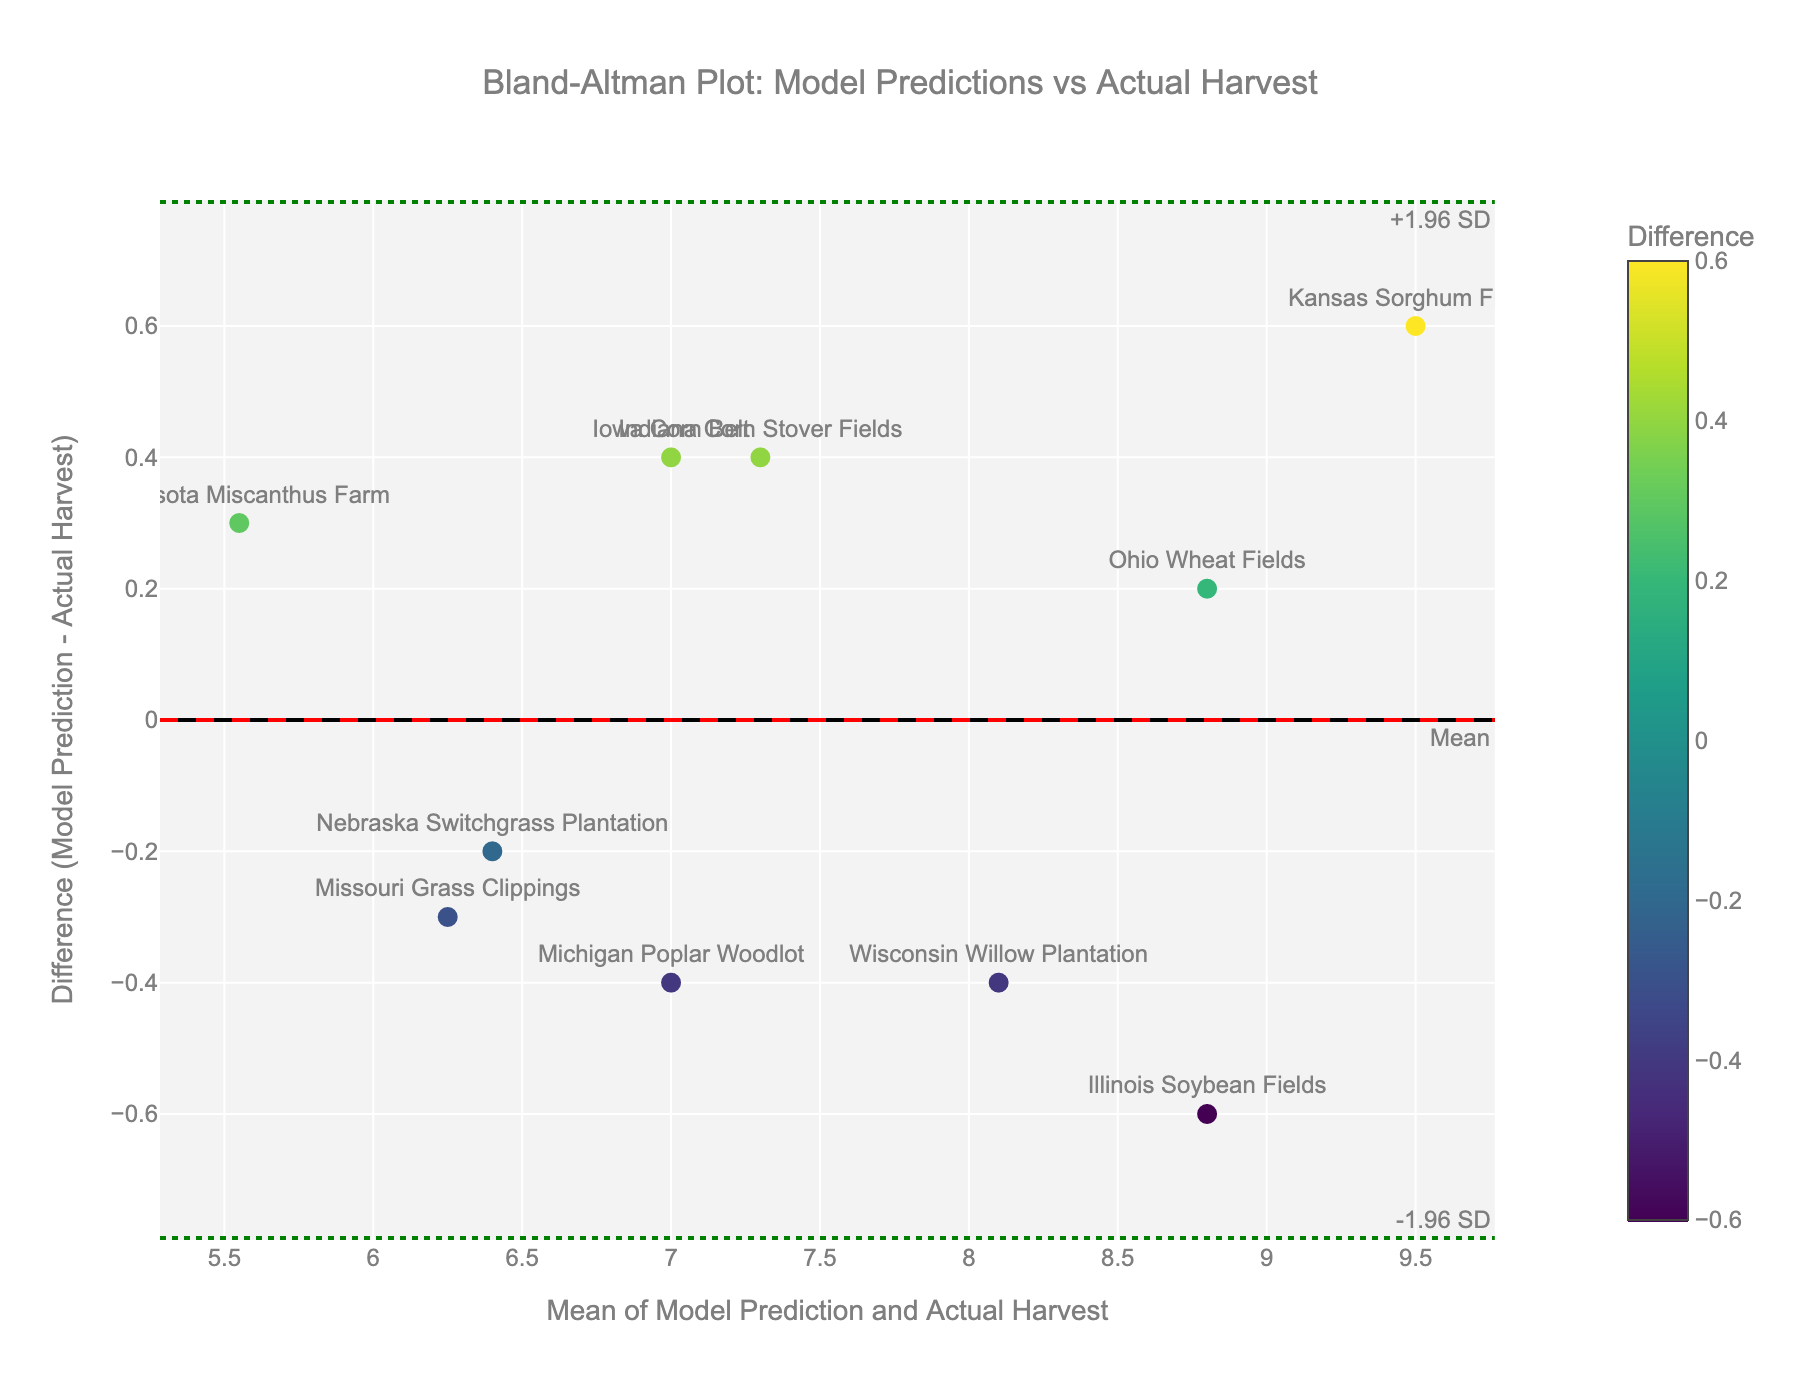How many data points are shown in the Bland-Altman plot? By counting each marker representing a location on the plot, we can identify 10 data points.
Answer: 10 What is the title of the plot? The title is found at the top center of the plot area. It reads: "Bland-Altman Plot: Model Predictions vs Actual Harvest".
Answer: Bland-Altman Plot: Model Predictions vs Actual Harvest What is the color of the mean difference line? The mean difference line is indicated by a horizontal dashed line colored in red.
Answer: Red Which location has the largest negative difference between model prediction and actual harvest? By examining the vertical positions of the markers on the y-axis, "Kansas Sorghum Fields" has the lowest (most negative) difference value among the data points, below the red mean difference line.
Answer: Kansas Sorghum Fields What are the y-values of the upper and lower Limits of Agreement (LOA) lines? The LOA lines are represented by green dotted lines with annotations. The upper LOA is marked with "+1.96 SD" and the lower LOA with "-1.96 SD". The exact y-values, based on the annotations, are the upper limit at approximately 1.24 and the lower limit at approximately -1.74.
Answer: Upper ~1.24 and Lower ~-1.74 How does the model prediction compare to the actual harvest on "Illinois Soybean Fields"? The marker for "Illinois Soybean Fields" is positioned above the mean difference line on the positive side, indicating the model prediction is lower than the actual harvest by observing the mean and difference values in the hover text.
Answer: Lower Which location has the mean closest to 7.5? Referring to the x-axis, the marker for "Indiana Corn Stover Fields" is closest to the mean value of 7.5.
Answer: Indiana Corn Stover Fields Which data point shows the maximum positive difference? The maximum positive difference is observed where the marker is at its highest y-value, which is for "Iowa Corn Belt".
Answer: Iowa Corn Belt What is the x-axis label of the plot? The label beneath the x-axis reads: "Mean of Model Prediction and Actual Harvest".
Answer: Mean of Model Prediction and Actual Harvest Which location shows a difference closest to zero? From the data points, "Nebraska Switchgrass Plantation" shows one of the smallest differences, plotted very close to the x-axis.
Answer: Nebraska Switchgrass Plantation 